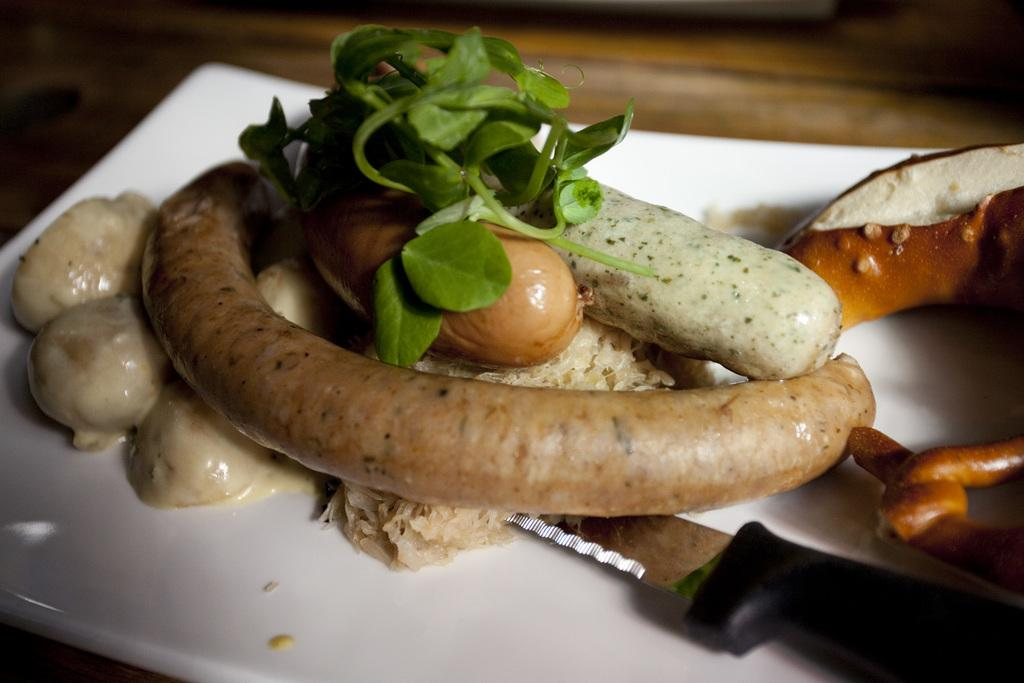What is on the plate that is visible in the image? There is food on a plate in the image. What utensil is on the plate in the image? There is a knife on the plate in the image. Where is the plate located in the image? The plate is placed on a table in the image. What grade does the food on the plate receive in the image? There is no indication of a grade for the food in the image. The image simply shows food on a plate with a knife. 